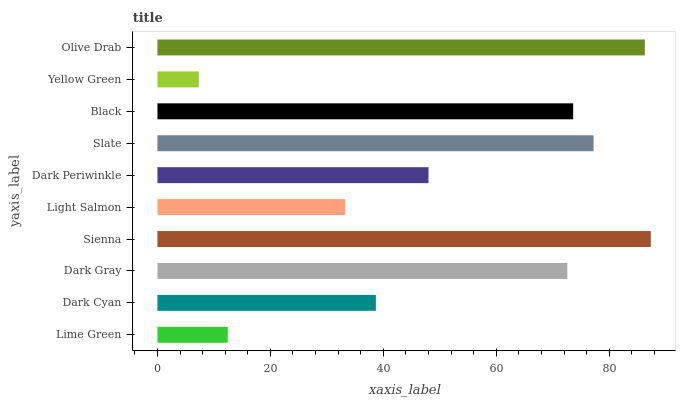Is Yellow Green the minimum?
Answer yes or no. Yes. Is Sienna the maximum?
Answer yes or no. Yes. Is Dark Cyan the minimum?
Answer yes or no. No. Is Dark Cyan the maximum?
Answer yes or no. No. Is Dark Cyan greater than Lime Green?
Answer yes or no. Yes. Is Lime Green less than Dark Cyan?
Answer yes or no. Yes. Is Lime Green greater than Dark Cyan?
Answer yes or no. No. Is Dark Cyan less than Lime Green?
Answer yes or no. No. Is Dark Gray the high median?
Answer yes or no. Yes. Is Dark Periwinkle the low median?
Answer yes or no. Yes. Is Sienna the high median?
Answer yes or no. No. Is Yellow Green the low median?
Answer yes or no. No. 